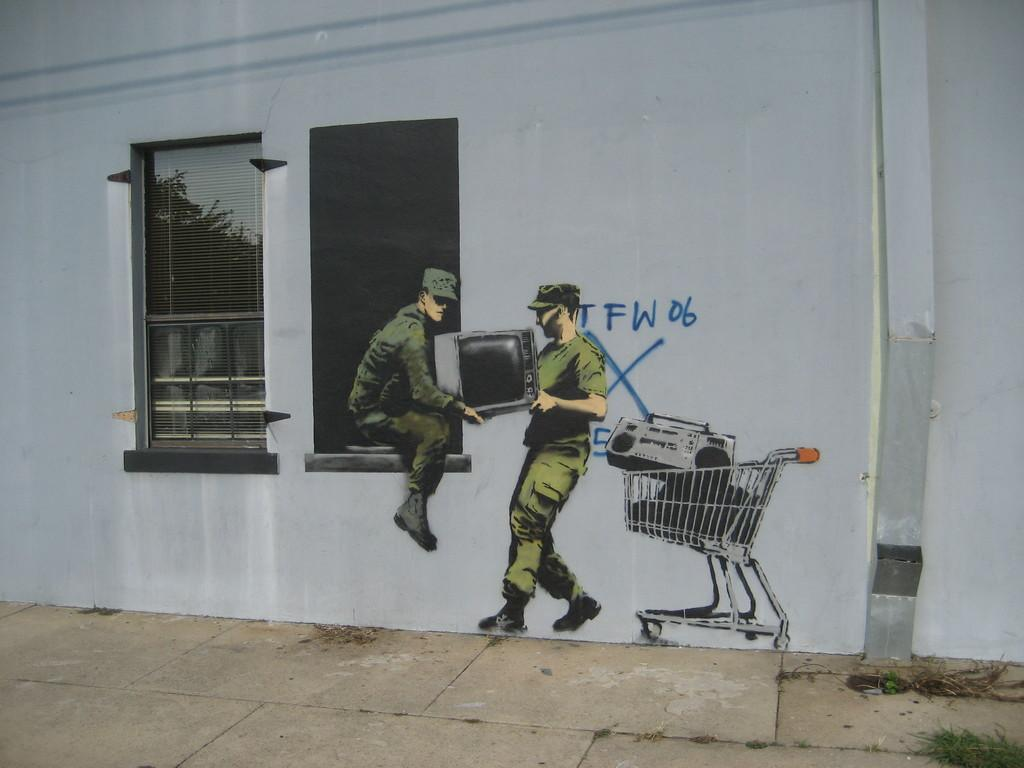How many people are present in the image? There are two people in the image. What are the two people doing in the image? The two people are holding a television. What other object can be seen in the image besides the television? There is a trolley in the image, which contains a tape recorder. What is visible in the background of the image? There is a wall and a window in the image. What type of lip balm is the person applying in the image? There is no lip balm or person applying it in the image; it features two people holding a television and a trolley with a tape recorder. 